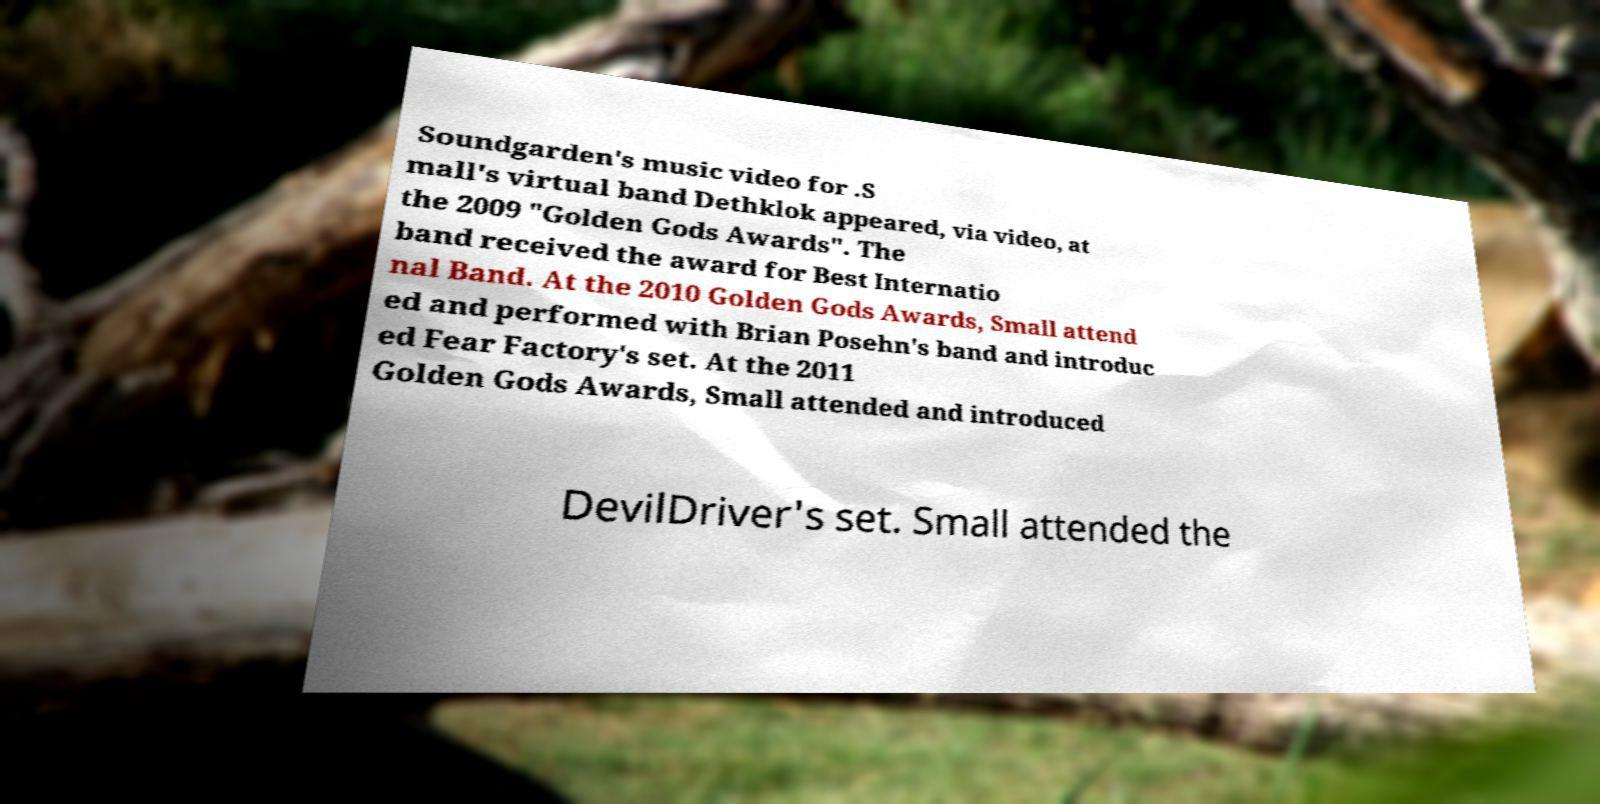I need the written content from this picture converted into text. Can you do that? Soundgarden's music video for .S mall's virtual band Dethklok appeared, via video, at the 2009 "Golden Gods Awards". The band received the award for Best Internatio nal Band. At the 2010 Golden Gods Awards, Small attend ed and performed with Brian Posehn's band and introduc ed Fear Factory's set. At the 2011 Golden Gods Awards, Small attended and introduced DevilDriver's set. Small attended the 